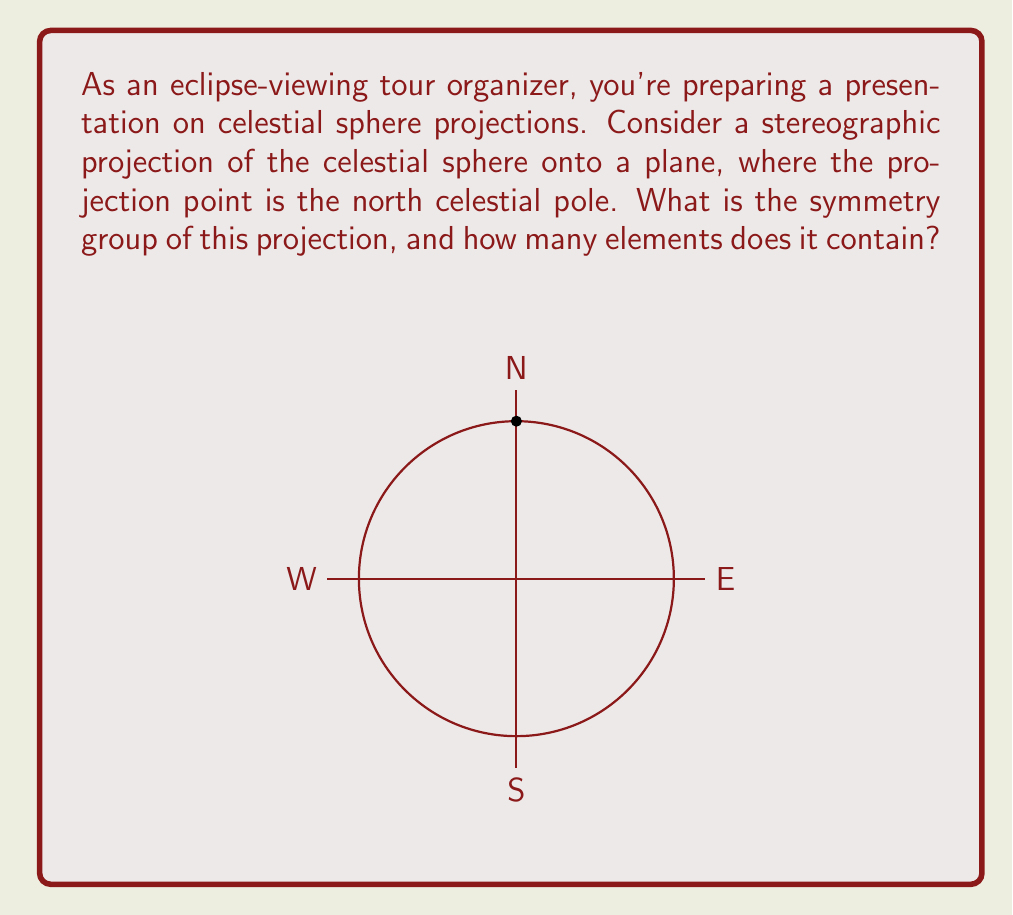Help me with this question. Let's approach this step-by-step:

1) The stereographic projection of a celestial sphere preserves circles and angles. This means that the symmetries of the projection will correspond to the symmetries of the plane that preserve circles and angles.

2) The symmetries that preserve circles and angles in the plane are known as conformal transformations. These include rotations, reflections, and inversions.

3) In this case, the projection point being the north celestial pole introduces a special condition. The north pole is mapped to infinity in the plane, while the south pole is mapped to the origin.

4) Given this setup, we can identify the following symmetries:
   a) Rotations around the origin (corresponding to rotations around the polar axis)
   b) Reflections across any line through the origin (corresponding to reflections across great circles through the poles)

5) These symmetries form the orthogonal group $O(2)$, which is the group of distance-preserving transformations of a two-dimensional Euclidean space that keep the origin fixed.

6) The group $O(2)$ can be described as the direct product of $SO(2)$ (the special orthogonal group, consisting of rotations) and $\mathbb{Z}_2$ (the group of order 2, representing reflections).

7) $SO(2)$ is infinite and continuous, representing rotations by any angle. $\mathbb{Z}_2$ has two elements, representing whether a reflection is applied or not.

8) Therefore, the symmetry group is $O(2)$, which has infinitely many elements due to the continuous nature of rotations.
Answer: $O(2)$, infinite elements 